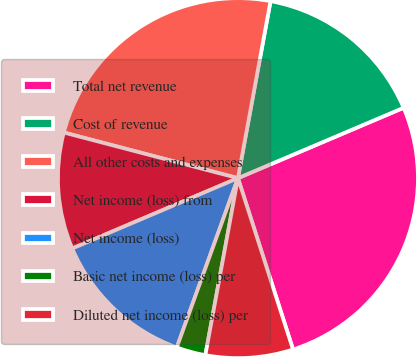Convert chart to OTSL. <chart><loc_0><loc_0><loc_500><loc_500><pie_chart><fcel>Total net revenue<fcel>Cost of revenue<fcel>All other costs and expenses<fcel>Net income (loss) from<fcel>Net income (loss)<fcel>Basic net income (loss) per<fcel>Diluted net income (loss) per<nl><fcel>26.44%<fcel>15.71%<fcel>23.82%<fcel>10.47%<fcel>13.09%<fcel>2.62%<fcel>7.85%<nl></chart> 